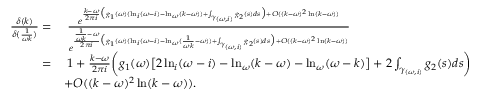<formula> <loc_0><loc_0><loc_500><loc_500>\begin{array} { r l } { \frac { \delta ( k ) } { \delta ( \frac { 1 } { \omega k } ) } = } & { \, \frac { e ^ { \frac { k - \omega } { 2 \pi i } \left ( g _ { 1 } ( \omega ) ( \ln _ { i } ( \omega - i ) - \ln _ { \omega } ( k - \omega ) ) + \int _ { \gamma _ { ( \omega , i ) } } g _ { 2 } ( s ) d s \right ) + O ( ( k - \omega ) ^ { 2 } \ln ( k - \omega ) ) } } { e ^ { \frac { \frac { 1 } { \omega k } - \omega } { 2 \pi i } \left ( g _ { 1 } ( \omega ) ( \ln _ { i } ( \omega - i ) - \ln _ { \omega } ( \frac { 1 } { \omega k } - \omega ) ) + \int _ { \gamma _ { ( \omega , i ) } } g _ { 2 } ( s ) d s \right ) + O ( ( k - \omega ) ^ { 2 } \ln ( k - \omega ) ) } } } \\ { = } & { \, 1 + \frac { k - \omega } { 2 \pi i } \left ( g _ { 1 } ( \omega ) \left [ 2 \ln _ { i } ( \omega - i ) - \ln _ { \omega } ( k - \omega ) - \ln _ { \omega } ( \omega - k ) \right ] + 2 \int _ { \gamma _ { ( \omega , i ) } } g _ { 2 } ( s ) d s \right ) } \\ & { + O ( ( k - \omega ) ^ { 2 } \ln ( k - \omega ) ) . } \end{array}</formula> 